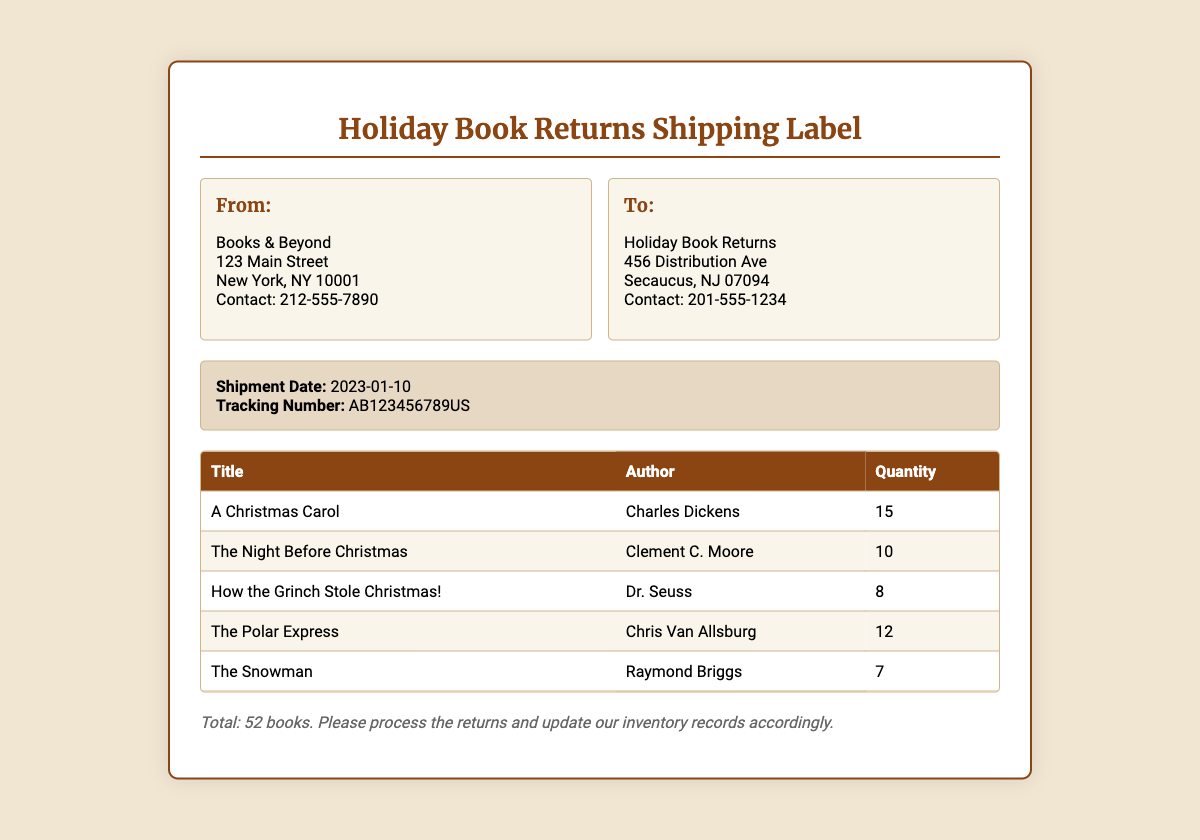What is the total quantity of books being returned? The total quantity of books is explicitly stated as "Total: 52 books."
Answer: 52 books Who is the author of "A Christmas Carol"? The document lists the author next to the title "A Christmas Carol," which is Charles Dickens.
Answer: Charles Dickens What is the shipment date? The shipment date is mentioned in the shipment details section as "2023-01-10."
Answer: 2023-01-10 How many copies of "The Polar Express" are being returned? The quantity for "The Polar Express" is provided in the table as "12."
Answer: 12 What is the contact number for the sender? The contact number for the sender, Books & Beyond, is displayed as "212-555-7890."
Answer: 212-555-7890 What address should the books be returned to? The address for returns is found in the "To:" section, specifically "Holiday Book Returns, 456 Distribution Ave, Secaucus, NJ 07094."
Answer: 456 Distribution Ave, Secaucus, NJ 07094 How many titles are listed for return? The table lists five different books, indicating the number of titles being returned.
Answer: 5 What is the tracking number for this shipment? The tracking number is clearly stated in the shipment details as "AB123456789US."
Answer: AB123456789US Who illustrated "The Snowman"? The document shows the author of "The Snowman" as Raymond Briggs, which typically is the same for the illustration.
Answer: Raymond Briggs 